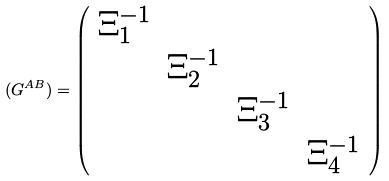Convert formula to latex. <formula><loc_0><loc_0><loc_500><loc_500>( G ^ { A B } ) = \left ( \begin{array} { c c c c } \Xi _ { 1 } ^ { - 1 } & & & \\ & \Xi _ { 2 } ^ { - 1 } & & \\ & & \Xi _ { 3 } ^ { - 1 } & \\ & & & \Xi _ { 4 } ^ { - 1 } \end{array} \right )</formula> 